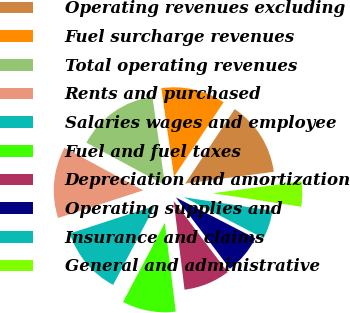Convert chart to OTSL. <chart><loc_0><loc_0><loc_500><loc_500><pie_chart><fcel>Operating revenues excluding<fcel>Fuel surcharge revenues<fcel>Total operating revenues<fcel>Rents and purchased<fcel>Salaries wages and employee<fcel>Fuel and fuel taxes<fcel>Depreciation and amortization<fcel>Operating supplies and<fcel>Insurance and claims<fcel>General and administrative<nl><fcel>13.55%<fcel>11.61%<fcel>14.84%<fcel>12.9%<fcel>12.26%<fcel>9.68%<fcel>8.39%<fcel>7.1%<fcel>5.16%<fcel>4.52%<nl></chart> 